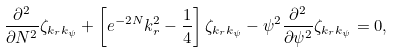Convert formula to latex. <formula><loc_0><loc_0><loc_500><loc_500>\frac { \partial ^ { 2 } } { \partial N ^ { 2 } } \zeta _ { k _ { r } k _ { \psi } } + \left [ e ^ { - 2 N } k _ { r } ^ { 2 } - \frac { 1 } { 4 } \right ] \zeta _ { k _ { r } k _ { \psi } } - \psi ^ { 2 } \frac { \partial ^ { 2 } } { \partial \psi ^ { 2 } } \zeta _ { k _ { r } k _ { \psi } } = 0 ,</formula> 